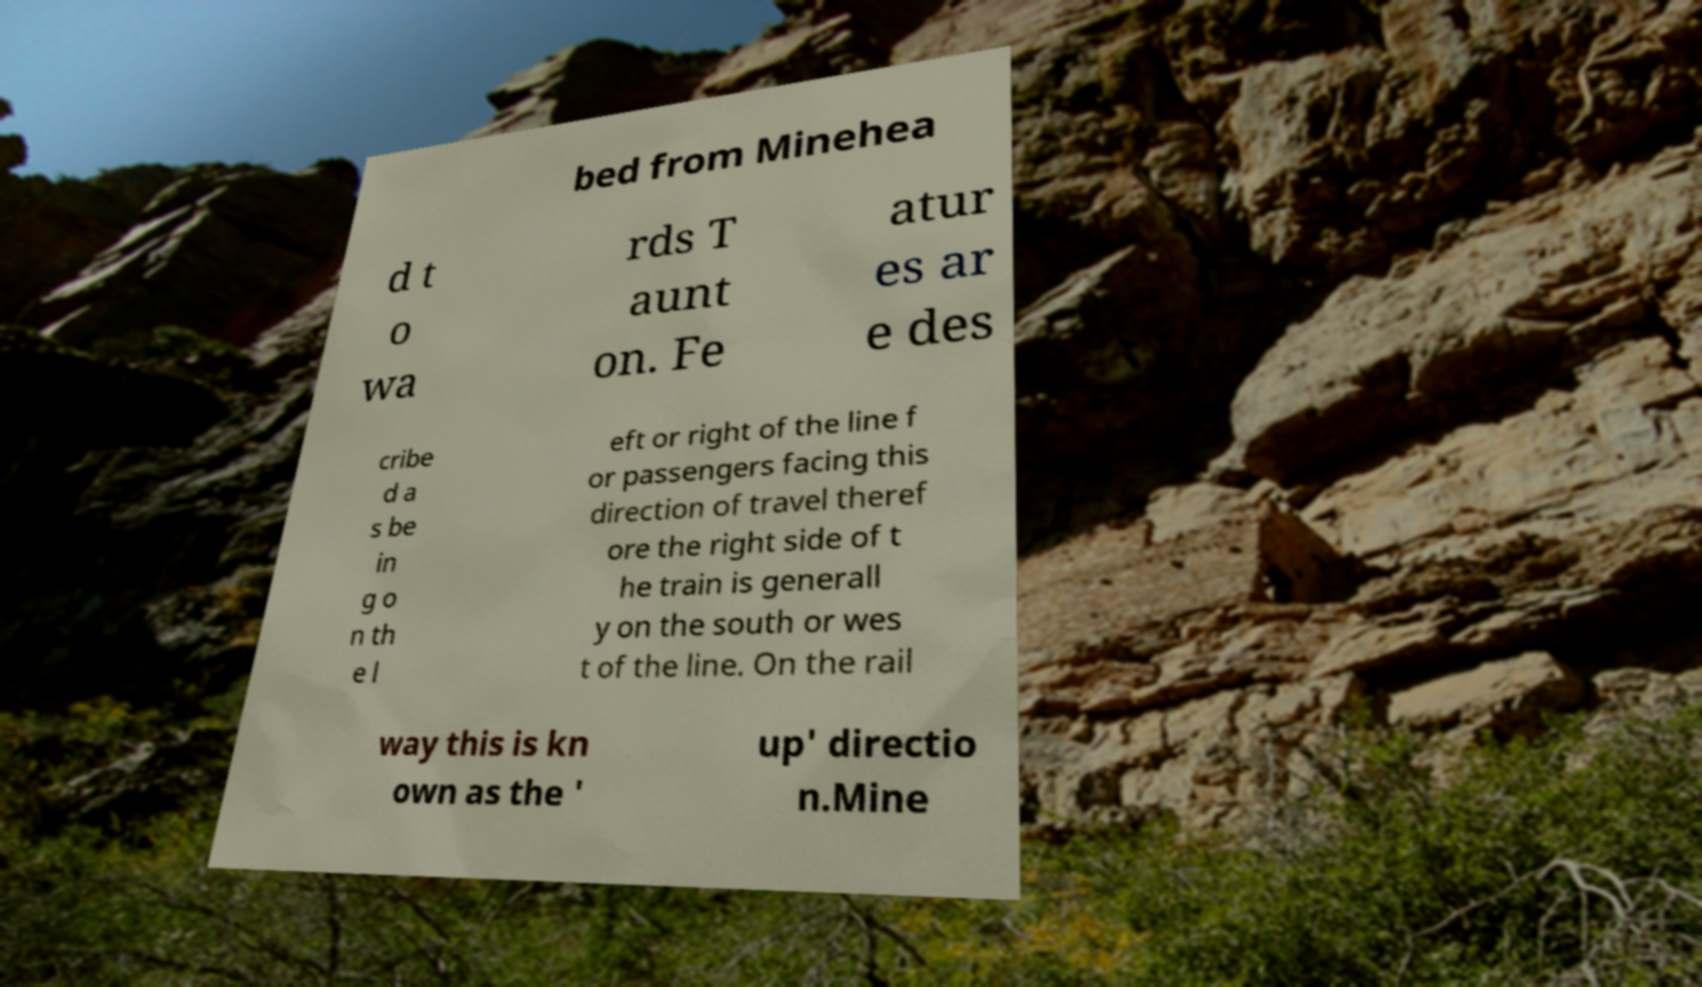Could you extract and type out the text from this image? bed from Minehea d t o wa rds T aunt on. Fe atur es ar e des cribe d a s be in g o n th e l eft or right of the line f or passengers facing this direction of travel theref ore the right side of t he train is generall y on the south or wes t of the line. On the rail way this is kn own as the ' up' directio n.Mine 